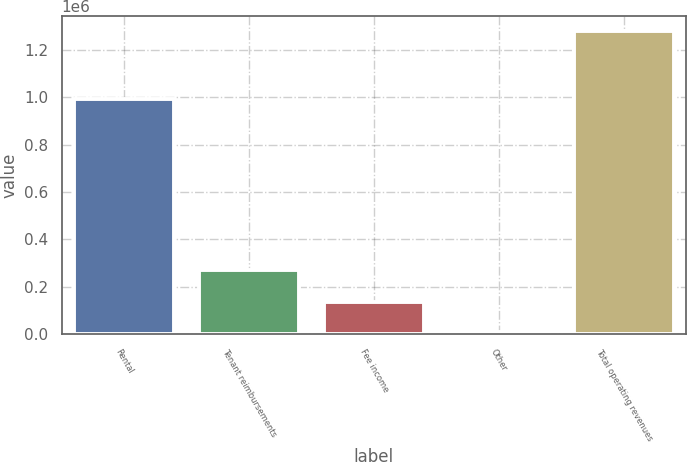Convert chart. <chart><loc_0><loc_0><loc_500><loc_500><bar_chart><fcel>Rental<fcel>Tenant reimbursements<fcel>Fee income<fcel>Other<fcel>Total operating revenues<nl><fcel>990715<fcel>272309<fcel>134760<fcel>7615<fcel>1.27907e+06<nl></chart> 